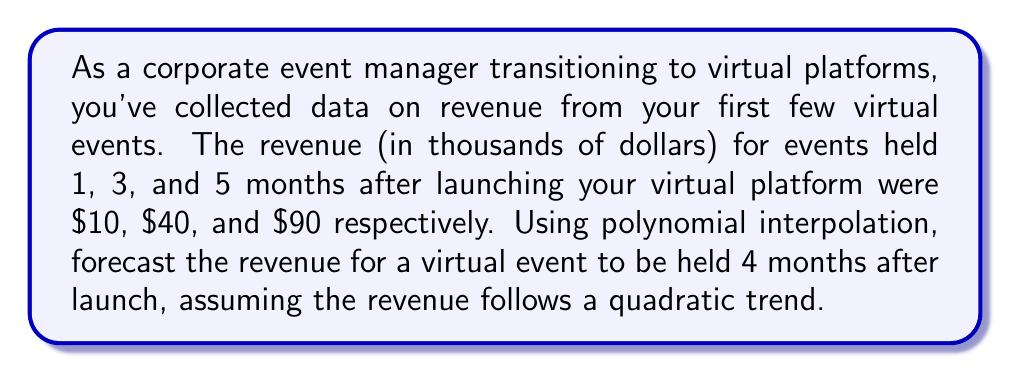What is the answer to this math problem? To solve this problem, we'll use quadratic polynomial interpolation. Let's follow these steps:

1) We're looking for a quadratic function of the form:
   $$f(x) = ax^2 + bx + c$$
   where $x$ is the number of months since launch.

2) We have three data points:
   $f(1) = 10$
   $f(3) = 40$
   $f(5) = 90$

3) Substituting these into our quadratic equation:
   $$10 = a(1)^2 + b(1) + c$$
   $$40 = a(3)^2 + b(3) + c$$
   $$90 = a(5)^2 + b(5) + c$$

4) Simplifying:
   $$10 = a + b + c$$
   $$40 = 9a + 3b + c$$
   $$90 = 25a + 5b + c$$

5) Subtracting the first equation from the second and third:
   $$30 = 8a + 2b$$
   $$80 = 24a + 4b$$

6) Dividing the first of these by 2:
   $$15 = 4a + b$$
   $$80 = 24a + 4b$$

7) Subtracting 4 times the first equation from the second:
   $$20 = 8a$$
   $$a = 2.5$$

8) Substituting back to find $b$:
   $$15 = 4(2.5) + b$$
   $$b = 5$$

9) Substituting into the first equation to find $c$:
   $$10 = 2.5 + 5 + c$$
   $$c = 2.5$$

10) Our quadratic function is:
    $$f(x) = 2.5x^2 + 5x + 2.5$$

11) To forecast revenue for 4 months after launch, we calculate $f(4)$:
    $$f(4) = 2.5(4)^2 + 5(4) + 2.5$$
    $$f(4) = 2.5(16) + 20 + 2.5$$
    $$f(4) = 40 + 20 + 2.5$$
    $$f(4) = 62.5$$

Therefore, the forecasted revenue for a virtual event 4 months after launch is $62,500.
Answer: $62,500 